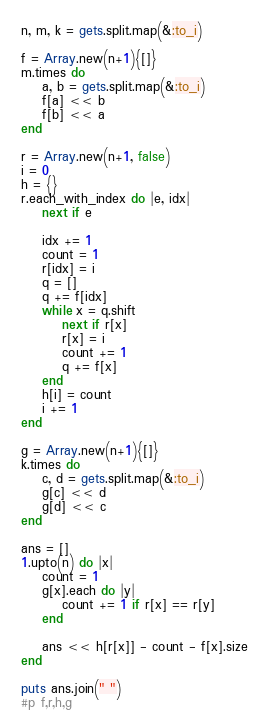Convert code to text. <code><loc_0><loc_0><loc_500><loc_500><_Ruby_>n, m, k = gets.split.map(&:to_i)

f = Array.new(n+1){[]}
m.times do
    a, b = gets.split.map(&:to_i)
    f[a] << b
    f[b] << a
end

r = Array.new(n+1, false)
i = 0
h = {}
r.each_with_index do |e, idx|
    next if e

    idx += 1
    count = 1
    r[idx] = i
    q = []
    q += f[idx]
    while x = q.shift
        next if r[x]
        r[x] = i
        count += 1
        q += f[x]
    end
    h[i] = count
    i += 1
end

g = Array.new(n+1){[]}
k.times do
    c, d = gets.split.map(&:to_i)
    g[c] << d
    g[d] << c
end

ans = []
1.upto(n) do |x|
    count = 1
    g[x].each do |y|
        count += 1 if r[x] == r[y]
    end

    ans << h[r[x]] - count - f[x].size
end

puts ans.join(" ")
#p f,r,h,g</code> 